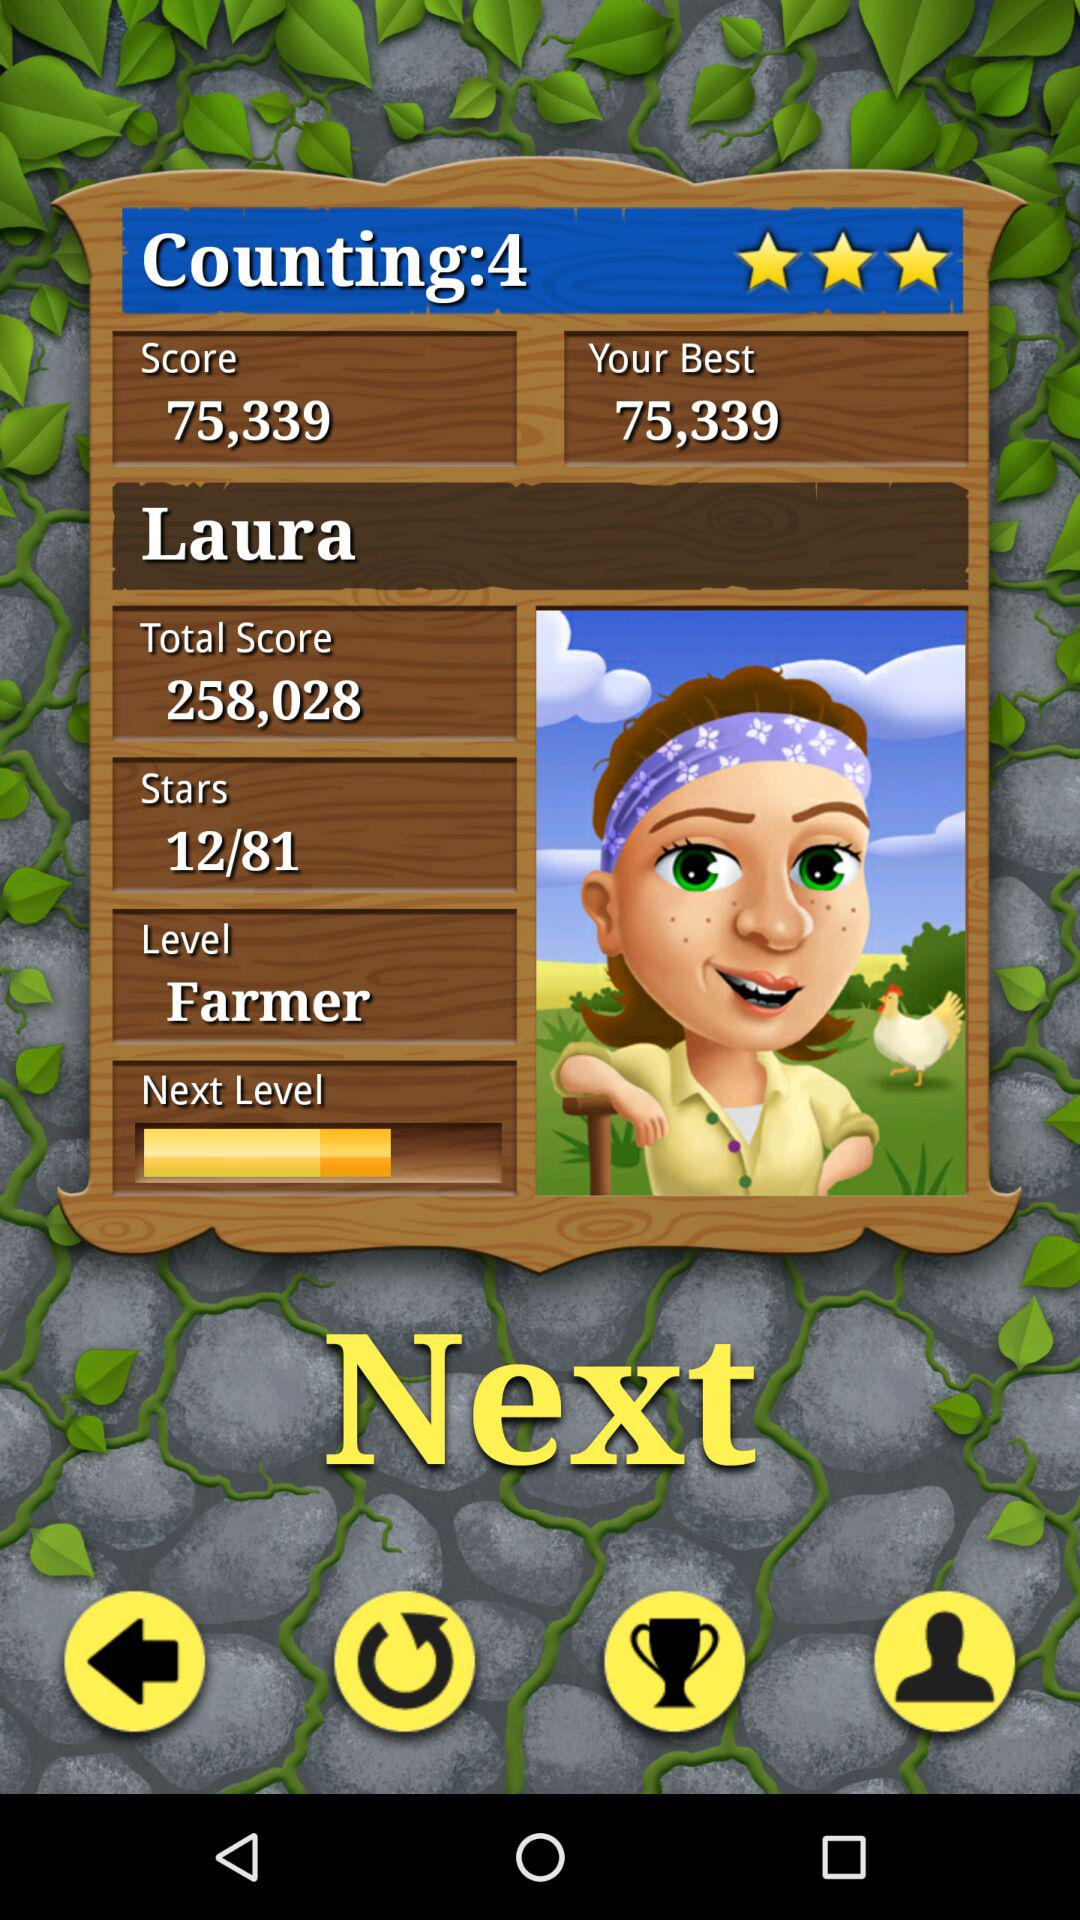What is the "Counting"? The "Counting" is 4. 